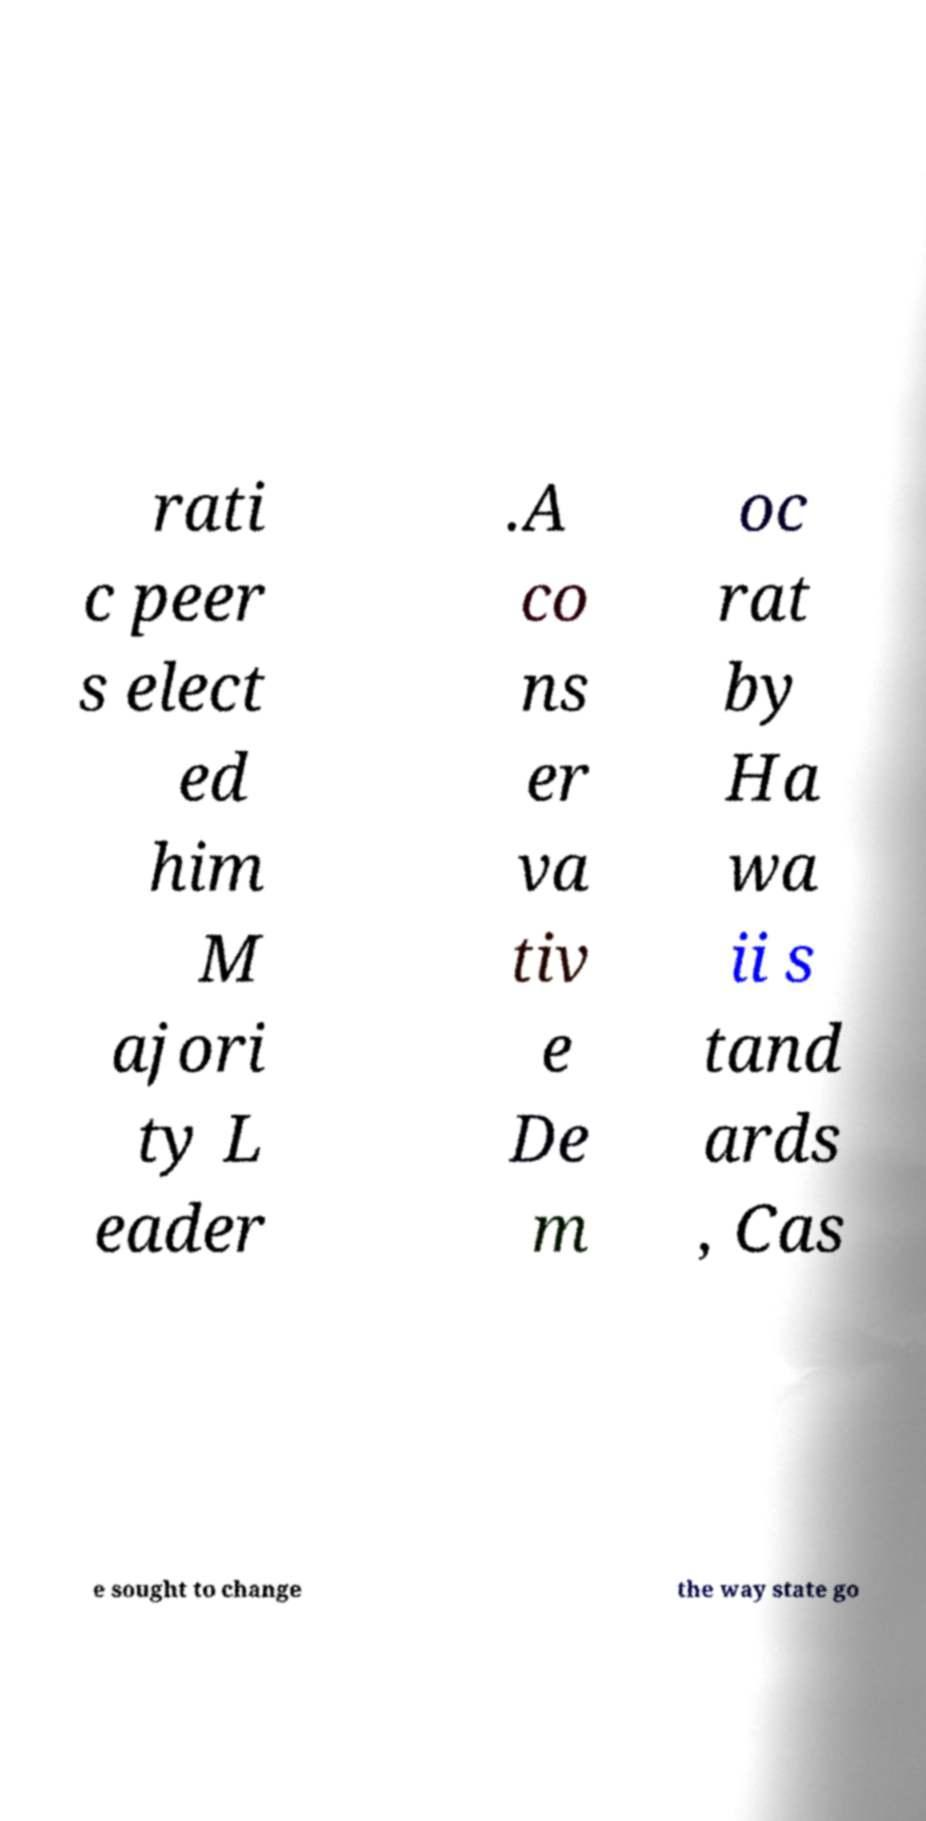Can you accurately transcribe the text from the provided image for me? rati c peer s elect ed him M ajori ty L eader .A co ns er va tiv e De m oc rat by Ha wa ii s tand ards , Cas e sought to change the way state go 